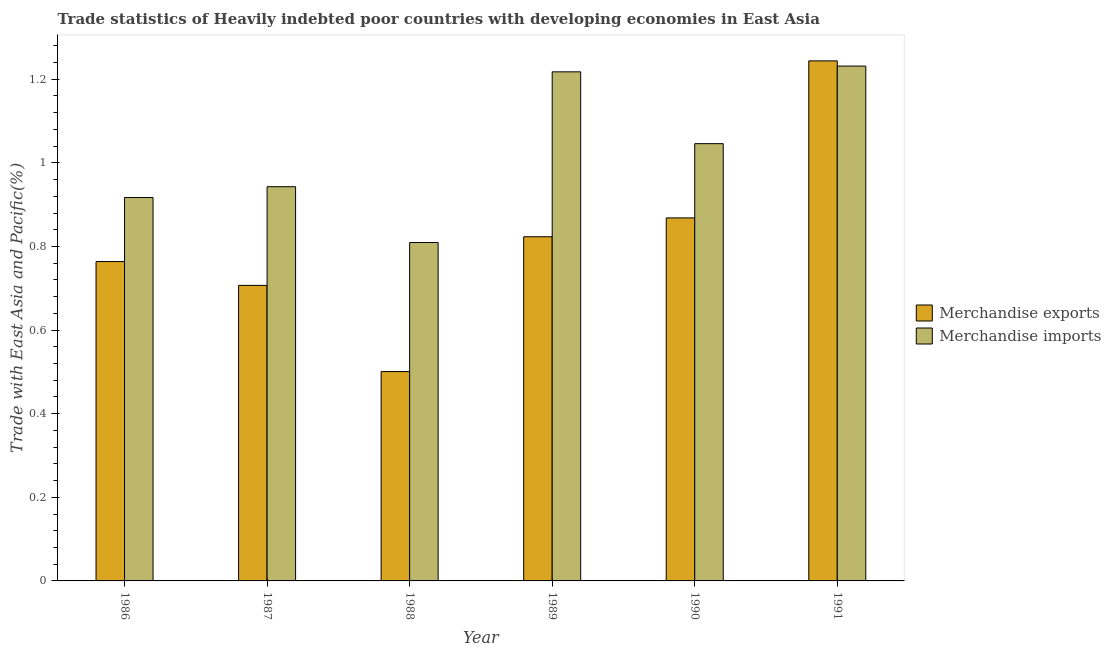How many different coloured bars are there?
Your answer should be compact. 2. How many groups of bars are there?
Your answer should be compact. 6. Are the number of bars on each tick of the X-axis equal?
Offer a terse response. Yes. What is the label of the 3rd group of bars from the left?
Keep it short and to the point. 1988. What is the merchandise exports in 1990?
Provide a succinct answer. 0.87. Across all years, what is the maximum merchandise exports?
Your answer should be compact. 1.24. Across all years, what is the minimum merchandise exports?
Your answer should be compact. 0.5. What is the total merchandise exports in the graph?
Keep it short and to the point. 4.91. What is the difference between the merchandise imports in 1989 and that in 1991?
Make the answer very short. -0.01. What is the difference between the merchandise exports in 1988 and the merchandise imports in 1987?
Offer a very short reply. -0.21. What is the average merchandise exports per year?
Provide a short and direct response. 0.82. In how many years, is the merchandise exports greater than 0.28 %?
Give a very brief answer. 6. What is the ratio of the merchandise exports in 1987 to that in 1991?
Your answer should be very brief. 0.57. Is the merchandise exports in 1989 less than that in 1991?
Your answer should be compact. Yes. What is the difference between the highest and the second highest merchandise exports?
Your answer should be compact. 0.38. What is the difference between the highest and the lowest merchandise imports?
Offer a very short reply. 0.42. In how many years, is the merchandise exports greater than the average merchandise exports taken over all years?
Keep it short and to the point. 3. How many bars are there?
Make the answer very short. 12. Does the graph contain any zero values?
Your answer should be very brief. No. Where does the legend appear in the graph?
Your response must be concise. Center right. How many legend labels are there?
Your answer should be compact. 2. How are the legend labels stacked?
Provide a succinct answer. Vertical. What is the title of the graph?
Your response must be concise. Trade statistics of Heavily indebted poor countries with developing economies in East Asia. What is the label or title of the X-axis?
Provide a succinct answer. Year. What is the label or title of the Y-axis?
Give a very brief answer. Trade with East Asia and Pacific(%). What is the Trade with East Asia and Pacific(%) in Merchandise exports in 1986?
Provide a short and direct response. 0.76. What is the Trade with East Asia and Pacific(%) in Merchandise imports in 1986?
Give a very brief answer. 0.92. What is the Trade with East Asia and Pacific(%) of Merchandise exports in 1987?
Make the answer very short. 0.71. What is the Trade with East Asia and Pacific(%) in Merchandise imports in 1987?
Offer a very short reply. 0.94. What is the Trade with East Asia and Pacific(%) in Merchandise exports in 1988?
Give a very brief answer. 0.5. What is the Trade with East Asia and Pacific(%) of Merchandise imports in 1988?
Keep it short and to the point. 0.81. What is the Trade with East Asia and Pacific(%) in Merchandise exports in 1989?
Your answer should be very brief. 0.82. What is the Trade with East Asia and Pacific(%) in Merchandise imports in 1989?
Your answer should be compact. 1.22. What is the Trade with East Asia and Pacific(%) in Merchandise exports in 1990?
Give a very brief answer. 0.87. What is the Trade with East Asia and Pacific(%) of Merchandise imports in 1990?
Ensure brevity in your answer.  1.05. What is the Trade with East Asia and Pacific(%) of Merchandise exports in 1991?
Offer a terse response. 1.24. What is the Trade with East Asia and Pacific(%) of Merchandise imports in 1991?
Provide a succinct answer. 1.23. Across all years, what is the maximum Trade with East Asia and Pacific(%) of Merchandise exports?
Make the answer very short. 1.24. Across all years, what is the maximum Trade with East Asia and Pacific(%) in Merchandise imports?
Give a very brief answer. 1.23. Across all years, what is the minimum Trade with East Asia and Pacific(%) in Merchandise exports?
Make the answer very short. 0.5. Across all years, what is the minimum Trade with East Asia and Pacific(%) in Merchandise imports?
Make the answer very short. 0.81. What is the total Trade with East Asia and Pacific(%) in Merchandise exports in the graph?
Give a very brief answer. 4.91. What is the total Trade with East Asia and Pacific(%) of Merchandise imports in the graph?
Offer a terse response. 6.16. What is the difference between the Trade with East Asia and Pacific(%) of Merchandise exports in 1986 and that in 1987?
Offer a terse response. 0.06. What is the difference between the Trade with East Asia and Pacific(%) of Merchandise imports in 1986 and that in 1987?
Provide a short and direct response. -0.03. What is the difference between the Trade with East Asia and Pacific(%) in Merchandise exports in 1986 and that in 1988?
Your answer should be compact. 0.26. What is the difference between the Trade with East Asia and Pacific(%) in Merchandise imports in 1986 and that in 1988?
Offer a very short reply. 0.11. What is the difference between the Trade with East Asia and Pacific(%) in Merchandise exports in 1986 and that in 1989?
Your response must be concise. -0.06. What is the difference between the Trade with East Asia and Pacific(%) in Merchandise imports in 1986 and that in 1989?
Your answer should be compact. -0.3. What is the difference between the Trade with East Asia and Pacific(%) in Merchandise exports in 1986 and that in 1990?
Your answer should be very brief. -0.1. What is the difference between the Trade with East Asia and Pacific(%) of Merchandise imports in 1986 and that in 1990?
Offer a terse response. -0.13. What is the difference between the Trade with East Asia and Pacific(%) in Merchandise exports in 1986 and that in 1991?
Your answer should be very brief. -0.48. What is the difference between the Trade with East Asia and Pacific(%) in Merchandise imports in 1986 and that in 1991?
Provide a short and direct response. -0.31. What is the difference between the Trade with East Asia and Pacific(%) of Merchandise exports in 1987 and that in 1988?
Your answer should be compact. 0.21. What is the difference between the Trade with East Asia and Pacific(%) of Merchandise imports in 1987 and that in 1988?
Offer a terse response. 0.13. What is the difference between the Trade with East Asia and Pacific(%) of Merchandise exports in 1987 and that in 1989?
Make the answer very short. -0.12. What is the difference between the Trade with East Asia and Pacific(%) of Merchandise imports in 1987 and that in 1989?
Your answer should be very brief. -0.27. What is the difference between the Trade with East Asia and Pacific(%) in Merchandise exports in 1987 and that in 1990?
Provide a short and direct response. -0.16. What is the difference between the Trade with East Asia and Pacific(%) of Merchandise imports in 1987 and that in 1990?
Ensure brevity in your answer.  -0.1. What is the difference between the Trade with East Asia and Pacific(%) in Merchandise exports in 1987 and that in 1991?
Offer a very short reply. -0.54. What is the difference between the Trade with East Asia and Pacific(%) of Merchandise imports in 1987 and that in 1991?
Provide a succinct answer. -0.29. What is the difference between the Trade with East Asia and Pacific(%) in Merchandise exports in 1988 and that in 1989?
Your response must be concise. -0.32. What is the difference between the Trade with East Asia and Pacific(%) in Merchandise imports in 1988 and that in 1989?
Offer a terse response. -0.41. What is the difference between the Trade with East Asia and Pacific(%) in Merchandise exports in 1988 and that in 1990?
Provide a short and direct response. -0.37. What is the difference between the Trade with East Asia and Pacific(%) in Merchandise imports in 1988 and that in 1990?
Give a very brief answer. -0.24. What is the difference between the Trade with East Asia and Pacific(%) in Merchandise exports in 1988 and that in 1991?
Keep it short and to the point. -0.74. What is the difference between the Trade with East Asia and Pacific(%) in Merchandise imports in 1988 and that in 1991?
Provide a succinct answer. -0.42. What is the difference between the Trade with East Asia and Pacific(%) in Merchandise exports in 1989 and that in 1990?
Offer a terse response. -0.05. What is the difference between the Trade with East Asia and Pacific(%) of Merchandise imports in 1989 and that in 1990?
Provide a short and direct response. 0.17. What is the difference between the Trade with East Asia and Pacific(%) of Merchandise exports in 1989 and that in 1991?
Your answer should be compact. -0.42. What is the difference between the Trade with East Asia and Pacific(%) in Merchandise imports in 1989 and that in 1991?
Your response must be concise. -0.01. What is the difference between the Trade with East Asia and Pacific(%) of Merchandise exports in 1990 and that in 1991?
Offer a terse response. -0.38. What is the difference between the Trade with East Asia and Pacific(%) of Merchandise imports in 1990 and that in 1991?
Offer a very short reply. -0.19. What is the difference between the Trade with East Asia and Pacific(%) of Merchandise exports in 1986 and the Trade with East Asia and Pacific(%) of Merchandise imports in 1987?
Your answer should be compact. -0.18. What is the difference between the Trade with East Asia and Pacific(%) of Merchandise exports in 1986 and the Trade with East Asia and Pacific(%) of Merchandise imports in 1988?
Your answer should be compact. -0.05. What is the difference between the Trade with East Asia and Pacific(%) of Merchandise exports in 1986 and the Trade with East Asia and Pacific(%) of Merchandise imports in 1989?
Offer a very short reply. -0.45. What is the difference between the Trade with East Asia and Pacific(%) of Merchandise exports in 1986 and the Trade with East Asia and Pacific(%) of Merchandise imports in 1990?
Give a very brief answer. -0.28. What is the difference between the Trade with East Asia and Pacific(%) of Merchandise exports in 1986 and the Trade with East Asia and Pacific(%) of Merchandise imports in 1991?
Provide a succinct answer. -0.47. What is the difference between the Trade with East Asia and Pacific(%) in Merchandise exports in 1987 and the Trade with East Asia and Pacific(%) in Merchandise imports in 1988?
Your answer should be compact. -0.1. What is the difference between the Trade with East Asia and Pacific(%) in Merchandise exports in 1987 and the Trade with East Asia and Pacific(%) in Merchandise imports in 1989?
Your answer should be very brief. -0.51. What is the difference between the Trade with East Asia and Pacific(%) of Merchandise exports in 1987 and the Trade with East Asia and Pacific(%) of Merchandise imports in 1990?
Offer a very short reply. -0.34. What is the difference between the Trade with East Asia and Pacific(%) of Merchandise exports in 1987 and the Trade with East Asia and Pacific(%) of Merchandise imports in 1991?
Your answer should be very brief. -0.52. What is the difference between the Trade with East Asia and Pacific(%) in Merchandise exports in 1988 and the Trade with East Asia and Pacific(%) in Merchandise imports in 1989?
Make the answer very short. -0.72. What is the difference between the Trade with East Asia and Pacific(%) of Merchandise exports in 1988 and the Trade with East Asia and Pacific(%) of Merchandise imports in 1990?
Your answer should be very brief. -0.55. What is the difference between the Trade with East Asia and Pacific(%) of Merchandise exports in 1988 and the Trade with East Asia and Pacific(%) of Merchandise imports in 1991?
Offer a very short reply. -0.73. What is the difference between the Trade with East Asia and Pacific(%) in Merchandise exports in 1989 and the Trade with East Asia and Pacific(%) in Merchandise imports in 1990?
Your answer should be compact. -0.22. What is the difference between the Trade with East Asia and Pacific(%) of Merchandise exports in 1989 and the Trade with East Asia and Pacific(%) of Merchandise imports in 1991?
Provide a short and direct response. -0.41. What is the difference between the Trade with East Asia and Pacific(%) of Merchandise exports in 1990 and the Trade with East Asia and Pacific(%) of Merchandise imports in 1991?
Keep it short and to the point. -0.36. What is the average Trade with East Asia and Pacific(%) of Merchandise exports per year?
Make the answer very short. 0.82. What is the average Trade with East Asia and Pacific(%) in Merchandise imports per year?
Your answer should be very brief. 1.03. In the year 1986, what is the difference between the Trade with East Asia and Pacific(%) in Merchandise exports and Trade with East Asia and Pacific(%) in Merchandise imports?
Ensure brevity in your answer.  -0.15. In the year 1987, what is the difference between the Trade with East Asia and Pacific(%) in Merchandise exports and Trade with East Asia and Pacific(%) in Merchandise imports?
Your answer should be compact. -0.24. In the year 1988, what is the difference between the Trade with East Asia and Pacific(%) of Merchandise exports and Trade with East Asia and Pacific(%) of Merchandise imports?
Make the answer very short. -0.31. In the year 1989, what is the difference between the Trade with East Asia and Pacific(%) of Merchandise exports and Trade with East Asia and Pacific(%) of Merchandise imports?
Give a very brief answer. -0.39. In the year 1990, what is the difference between the Trade with East Asia and Pacific(%) of Merchandise exports and Trade with East Asia and Pacific(%) of Merchandise imports?
Ensure brevity in your answer.  -0.18. In the year 1991, what is the difference between the Trade with East Asia and Pacific(%) of Merchandise exports and Trade with East Asia and Pacific(%) of Merchandise imports?
Your response must be concise. 0.01. What is the ratio of the Trade with East Asia and Pacific(%) of Merchandise exports in 1986 to that in 1987?
Your response must be concise. 1.08. What is the ratio of the Trade with East Asia and Pacific(%) in Merchandise imports in 1986 to that in 1987?
Make the answer very short. 0.97. What is the ratio of the Trade with East Asia and Pacific(%) of Merchandise exports in 1986 to that in 1988?
Your answer should be very brief. 1.53. What is the ratio of the Trade with East Asia and Pacific(%) in Merchandise imports in 1986 to that in 1988?
Give a very brief answer. 1.13. What is the ratio of the Trade with East Asia and Pacific(%) in Merchandise exports in 1986 to that in 1989?
Provide a succinct answer. 0.93. What is the ratio of the Trade with East Asia and Pacific(%) in Merchandise imports in 1986 to that in 1989?
Give a very brief answer. 0.75. What is the ratio of the Trade with East Asia and Pacific(%) in Merchandise exports in 1986 to that in 1990?
Your answer should be very brief. 0.88. What is the ratio of the Trade with East Asia and Pacific(%) of Merchandise imports in 1986 to that in 1990?
Offer a very short reply. 0.88. What is the ratio of the Trade with East Asia and Pacific(%) of Merchandise exports in 1986 to that in 1991?
Ensure brevity in your answer.  0.61. What is the ratio of the Trade with East Asia and Pacific(%) in Merchandise imports in 1986 to that in 1991?
Your answer should be very brief. 0.74. What is the ratio of the Trade with East Asia and Pacific(%) in Merchandise exports in 1987 to that in 1988?
Ensure brevity in your answer.  1.41. What is the ratio of the Trade with East Asia and Pacific(%) of Merchandise imports in 1987 to that in 1988?
Provide a short and direct response. 1.16. What is the ratio of the Trade with East Asia and Pacific(%) in Merchandise exports in 1987 to that in 1989?
Your answer should be compact. 0.86. What is the ratio of the Trade with East Asia and Pacific(%) of Merchandise imports in 1987 to that in 1989?
Offer a terse response. 0.77. What is the ratio of the Trade with East Asia and Pacific(%) in Merchandise exports in 1987 to that in 1990?
Make the answer very short. 0.81. What is the ratio of the Trade with East Asia and Pacific(%) in Merchandise imports in 1987 to that in 1990?
Your response must be concise. 0.9. What is the ratio of the Trade with East Asia and Pacific(%) in Merchandise exports in 1987 to that in 1991?
Keep it short and to the point. 0.57. What is the ratio of the Trade with East Asia and Pacific(%) in Merchandise imports in 1987 to that in 1991?
Keep it short and to the point. 0.77. What is the ratio of the Trade with East Asia and Pacific(%) in Merchandise exports in 1988 to that in 1989?
Provide a succinct answer. 0.61. What is the ratio of the Trade with East Asia and Pacific(%) in Merchandise imports in 1988 to that in 1989?
Provide a short and direct response. 0.66. What is the ratio of the Trade with East Asia and Pacific(%) of Merchandise exports in 1988 to that in 1990?
Your response must be concise. 0.58. What is the ratio of the Trade with East Asia and Pacific(%) of Merchandise imports in 1988 to that in 1990?
Give a very brief answer. 0.77. What is the ratio of the Trade with East Asia and Pacific(%) of Merchandise exports in 1988 to that in 1991?
Offer a terse response. 0.4. What is the ratio of the Trade with East Asia and Pacific(%) in Merchandise imports in 1988 to that in 1991?
Make the answer very short. 0.66. What is the ratio of the Trade with East Asia and Pacific(%) in Merchandise exports in 1989 to that in 1990?
Your answer should be very brief. 0.95. What is the ratio of the Trade with East Asia and Pacific(%) of Merchandise imports in 1989 to that in 1990?
Offer a terse response. 1.16. What is the ratio of the Trade with East Asia and Pacific(%) in Merchandise exports in 1989 to that in 1991?
Your answer should be compact. 0.66. What is the ratio of the Trade with East Asia and Pacific(%) in Merchandise imports in 1989 to that in 1991?
Provide a short and direct response. 0.99. What is the ratio of the Trade with East Asia and Pacific(%) in Merchandise exports in 1990 to that in 1991?
Your answer should be compact. 0.7. What is the ratio of the Trade with East Asia and Pacific(%) in Merchandise imports in 1990 to that in 1991?
Ensure brevity in your answer.  0.85. What is the difference between the highest and the second highest Trade with East Asia and Pacific(%) in Merchandise exports?
Offer a terse response. 0.38. What is the difference between the highest and the second highest Trade with East Asia and Pacific(%) in Merchandise imports?
Your response must be concise. 0.01. What is the difference between the highest and the lowest Trade with East Asia and Pacific(%) in Merchandise exports?
Offer a very short reply. 0.74. What is the difference between the highest and the lowest Trade with East Asia and Pacific(%) of Merchandise imports?
Your response must be concise. 0.42. 